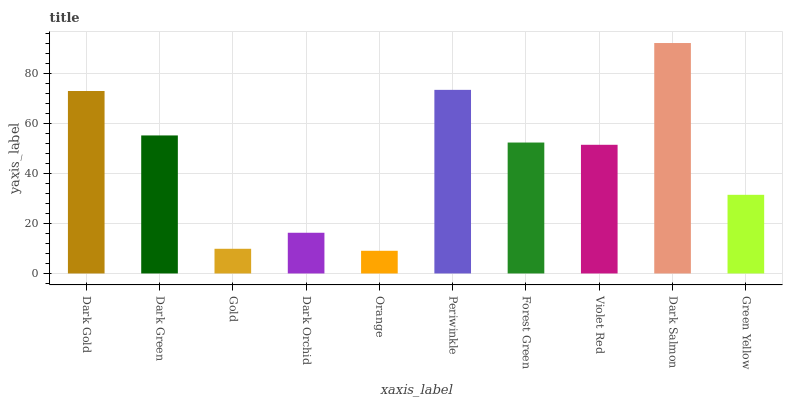Is Orange the minimum?
Answer yes or no. Yes. Is Dark Salmon the maximum?
Answer yes or no. Yes. Is Dark Green the minimum?
Answer yes or no. No. Is Dark Green the maximum?
Answer yes or no. No. Is Dark Gold greater than Dark Green?
Answer yes or no. Yes. Is Dark Green less than Dark Gold?
Answer yes or no. Yes. Is Dark Green greater than Dark Gold?
Answer yes or no. No. Is Dark Gold less than Dark Green?
Answer yes or no. No. Is Forest Green the high median?
Answer yes or no. Yes. Is Violet Red the low median?
Answer yes or no. Yes. Is Violet Red the high median?
Answer yes or no. No. Is Periwinkle the low median?
Answer yes or no. No. 